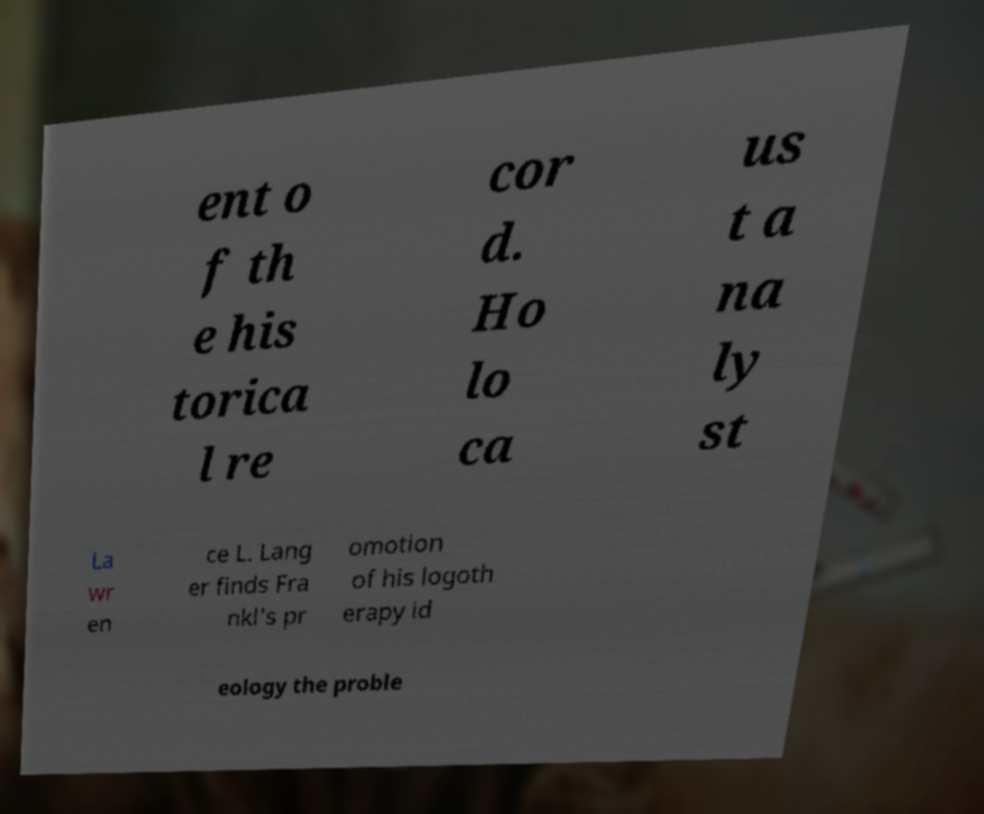What messages or text are displayed in this image? I need them in a readable, typed format. ent o f th e his torica l re cor d. Ho lo ca us t a na ly st La wr en ce L. Lang er finds Fra nkl's pr omotion of his logoth erapy id eology the proble 